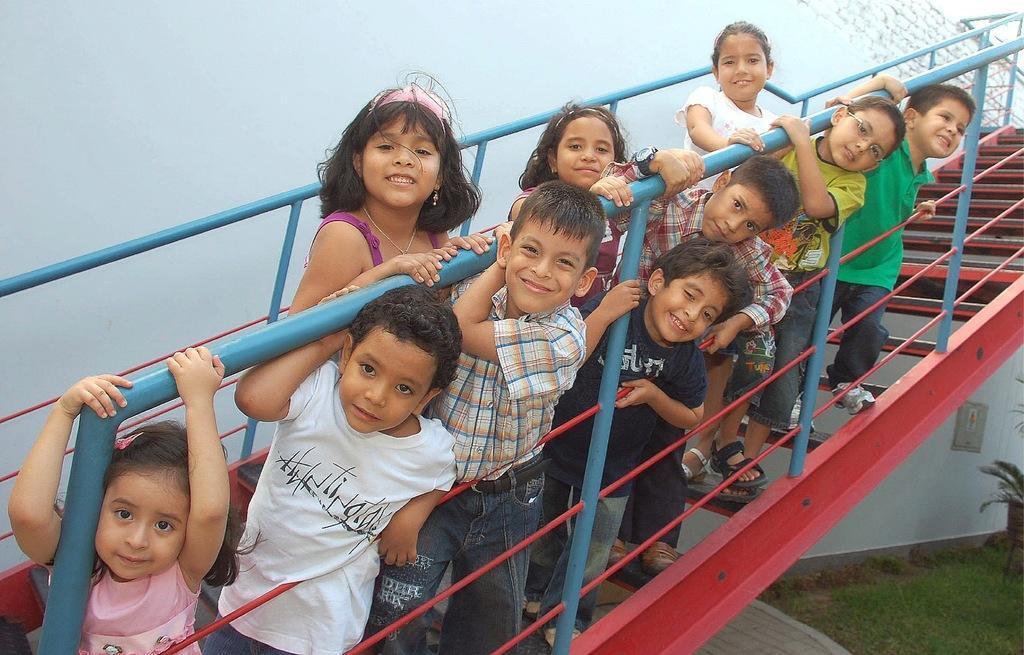Please provide a concise description of this image. In this image we can see some children on the staircase which is attached to the building and we can see the grass on the ground and a plant. 